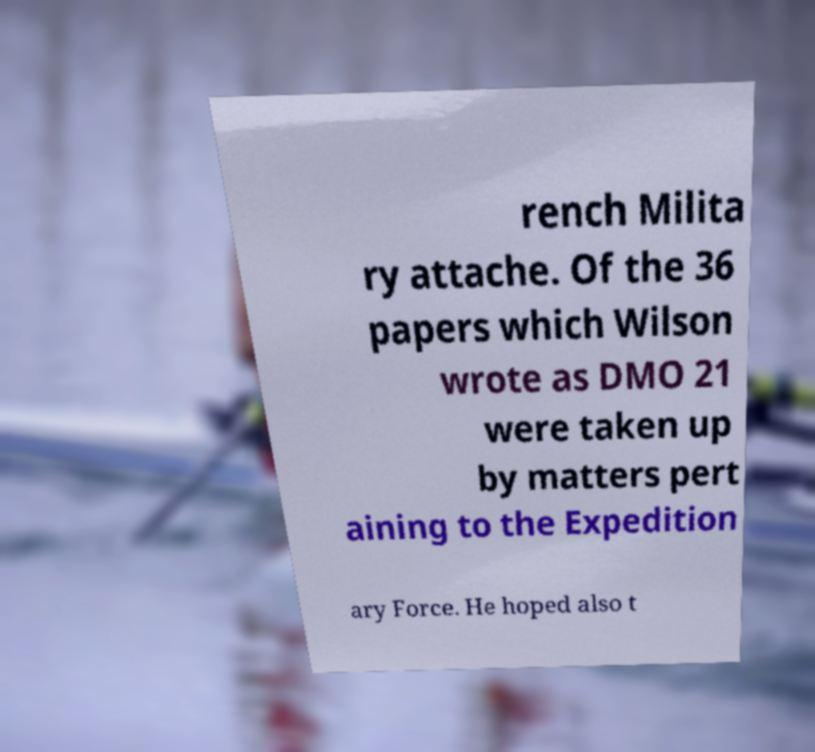For documentation purposes, I need the text within this image transcribed. Could you provide that? rench Milita ry attache. Of the 36 papers which Wilson wrote as DMO 21 were taken up by matters pert aining to the Expedition ary Force. He hoped also t 